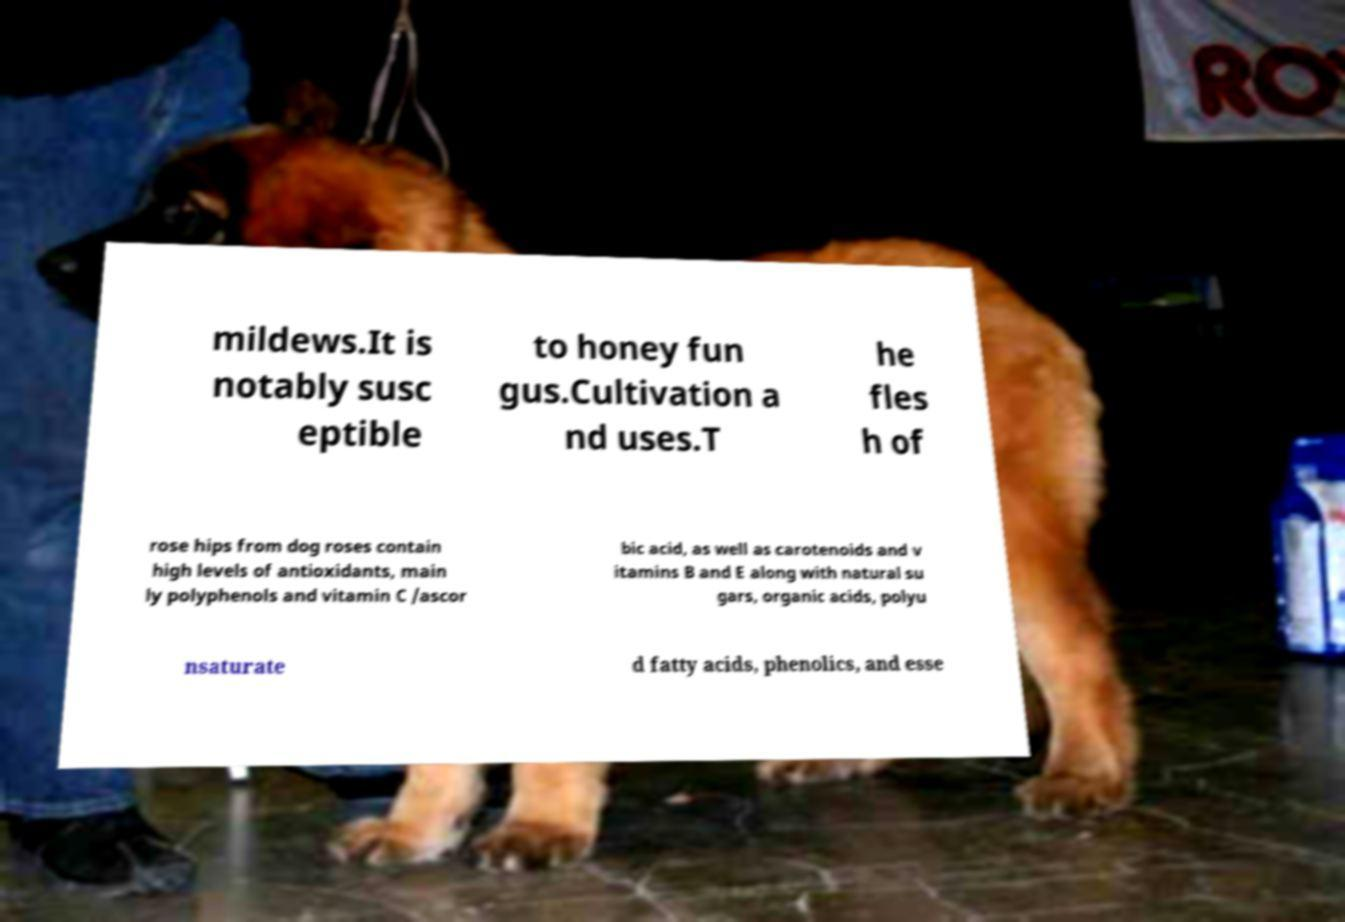Please read and relay the text visible in this image. What does it say? mildews.It is notably susc eptible to honey fun gus.Cultivation a nd uses.T he fles h of rose hips from dog roses contain high levels of antioxidants, main ly polyphenols and vitamin C /ascor bic acid, as well as carotenoids and v itamins B and E along with natural su gars, organic acids, polyu nsaturate d fatty acids, phenolics, and esse 